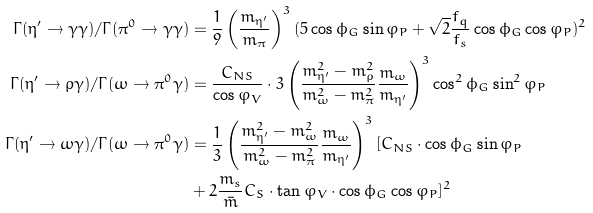<formula> <loc_0><loc_0><loc_500><loc_500>\Gamma ( \eta ^ { \prime } \rightarrow \gamma \gamma ) / \Gamma ( \pi ^ { 0 } \rightarrow \gamma \gamma ) & = \frac { 1 } { 9 } \left ( \frac { m _ { \eta ^ { \prime } } } { m _ { \pi } } \right ) ^ { 3 } ( 5 \cos \phi _ { G } \sin \varphi _ { P } + \sqrt { 2 } \frac { f _ { q } } { f _ { s } } \cos \phi _ { G } \cos \varphi _ { P } ) ^ { 2 } \\ \Gamma ( \eta ^ { \prime } \rightarrow \rho \gamma ) / \Gamma ( \omega \rightarrow \pi ^ { 0 } \gamma ) & = \frac { C _ { N S } } { \cos \varphi _ { V } } \cdot 3 \left ( \frac { m _ { \eta ^ { \prime } } ^ { 2 } - m _ { \rho } ^ { 2 } } { m _ { \omega } ^ { 2 } - m _ { \pi } ^ { 2 } } \frac { m _ { \omega } } { m _ { \eta ^ { \prime } } } \right ) ^ { 3 } \cos ^ { 2 } \phi _ { G } \sin ^ { 2 } \varphi _ { P } \\ \Gamma ( \eta ^ { \prime } \rightarrow \omega \gamma ) / \Gamma ( \omega \rightarrow \pi ^ { 0 } \gamma ) & = \frac { 1 } { 3 } \left ( \frac { m _ { \eta ^ { \prime } } ^ { 2 } - m _ { \omega } ^ { 2 } } { m _ { \omega } ^ { 2 } - m _ { \pi } ^ { 2 } } \frac { m _ { \omega } } { m _ { \eta ^ { \prime } } } \right ) ^ { 3 } [ C _ { N S } \cdot \cos \phi _ { G } \sin \varphi _ { P } \\ & + 2 \frac { m _ { s } } { \bar { m } } C _ { S } \cdot \tan \varphi _ { V } \cdot \cos \phi _ { G } \cos \varphi _ { P } ] ^ { 2 }</formula> 